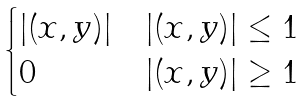Convert formula to latex. <formula><loc_0><loc_0><loc_500><loc_500>\begin{cases} | ( x , y ) | & | ( x , y ) | \leq 1 \\ 0 & | ( x , y ) | \geq 1 \end{cases}</formula> 